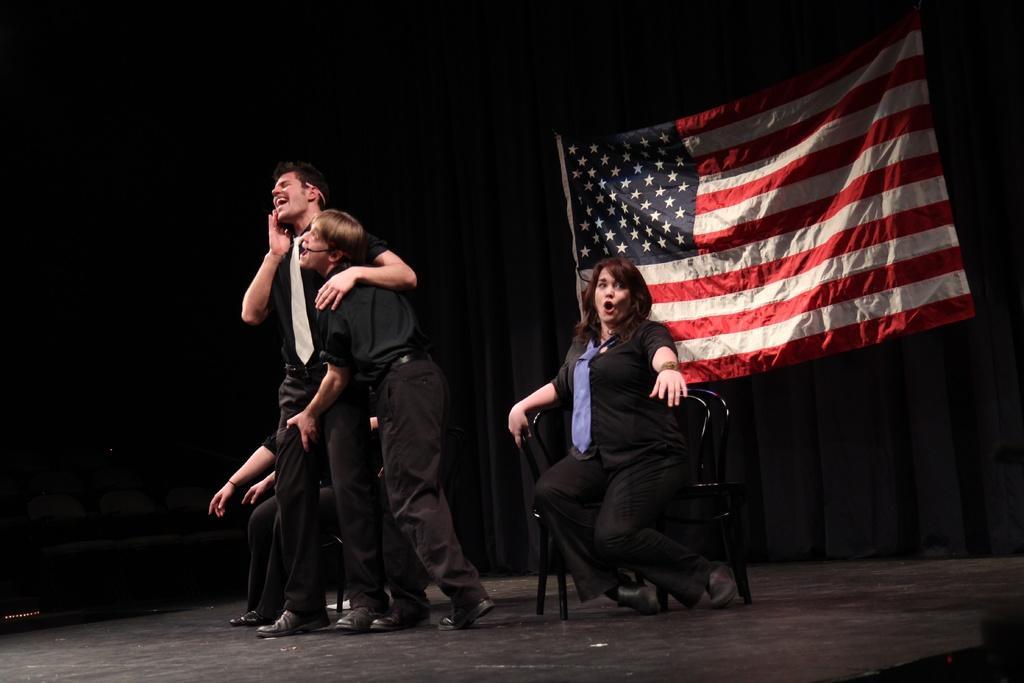How would you summarize this image in a sentence or two? In this image there are some people sitting and standing on the stage doing some play, behind them there is a flag on the wall. 